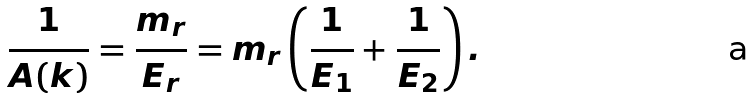Convert formula to latex. <formula><loc_0><loc_0><loc_500><loc_500>\frac { 1 } { A ( k ) } = \frac { m _ { r } } { E _ { r } } = m _ { r } \left ( \frac { 1 } { E _ { 1 } } + \frac { 1 } { E _ { 2 } } \right ) .</formula> 